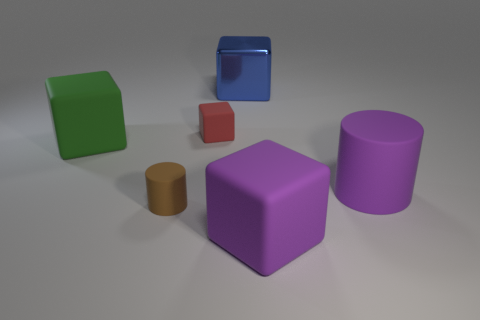Could you describe the lighting in the scene? The scene is softly lit, with diffuse overhead lighting that casts gentle shadows on the ground beneath the objects. There are no harsh shadows or bright highlights, which creates a calm and neutral atmosphere. The lighting appears to be uniform and doesn't strongly favor any particular direction. 